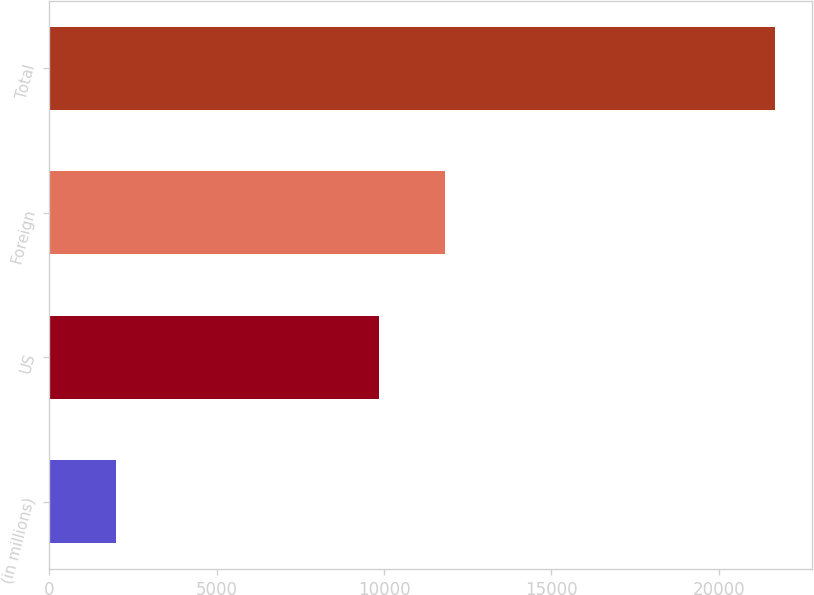Convert chart to OTSL. <chart><loc_0><loc_0><loc_500><loc_500><bar_chart><fcel>(in millions)<fcel>US<fcel>Foreign<fcel>Total<nl><fcel>2006<fcel>9862<fcel>11830.1<fcel>21687<nl></chart> 